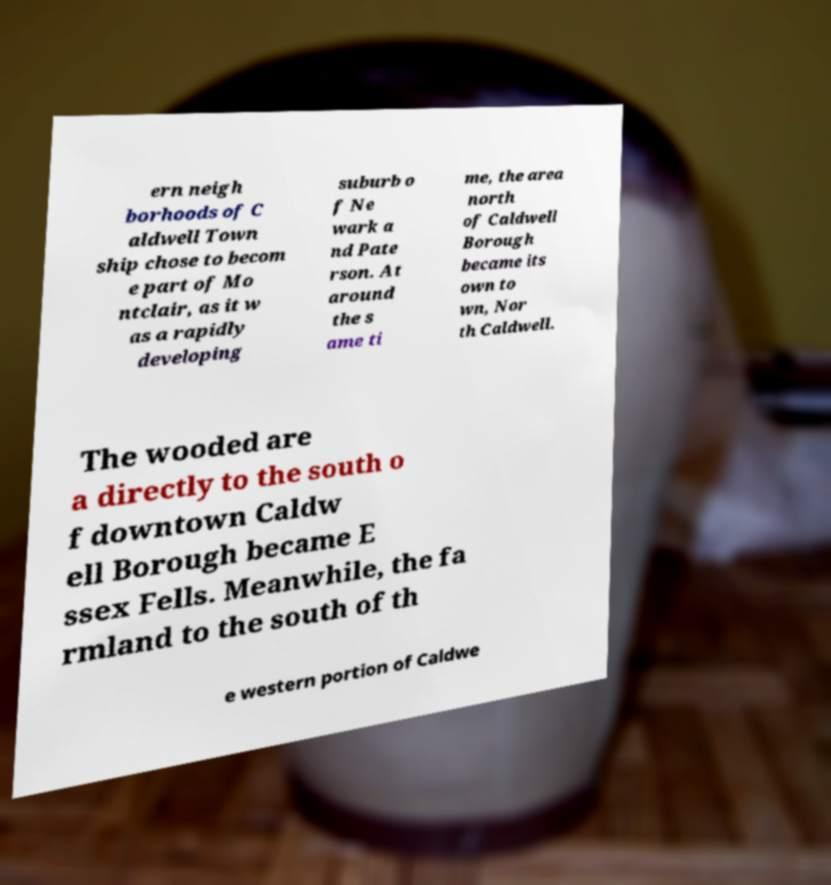There's text embedded in this image that I need extracted. Can you transcribe it verbatim? ern neigh borhoods of C aldwell Town ship chose to becom e part of Mo ntclair, as it w as a rapidly developing suburb o f Ne wark a nd Pate rson. At around the s ame ti me, the area north of Caldwell Borough became its own to wn, Nor th Caldwell. The wooded are a directly to the south o f downtown Caldw ell Borough became E ssex Fells. Meanwhile, the fa rmland to the south of th e western portion of Caldwe 